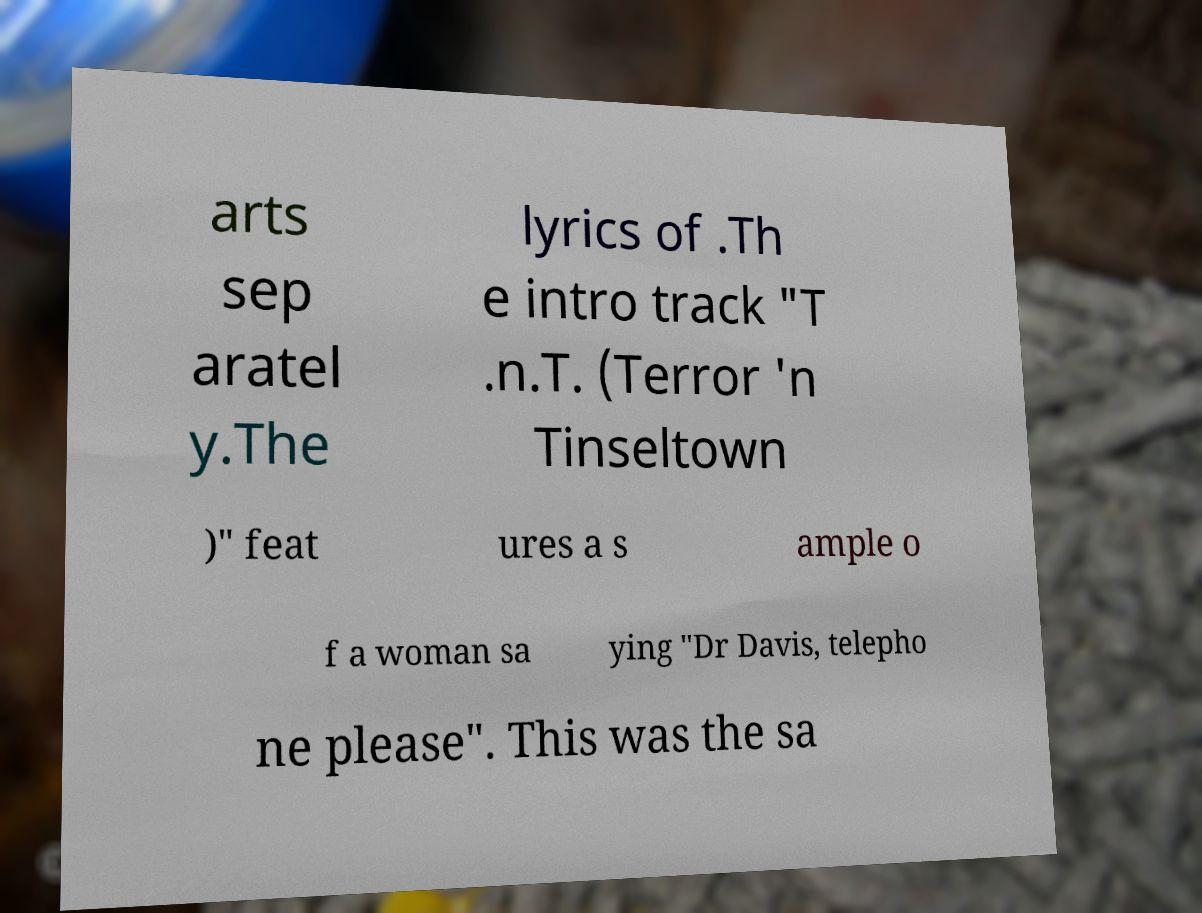Can you read and provide the text displayed in the image?This photo seems to have some interesting text. Can you extract and type it out for me? arts sep aratel y.The lyrics of .Th e intro track "T .n.T. (Terror 'n Tinseltown )" feat ures a s ample o f a woman sa ying "Dr Davis, telepho ne please". This was the sa 